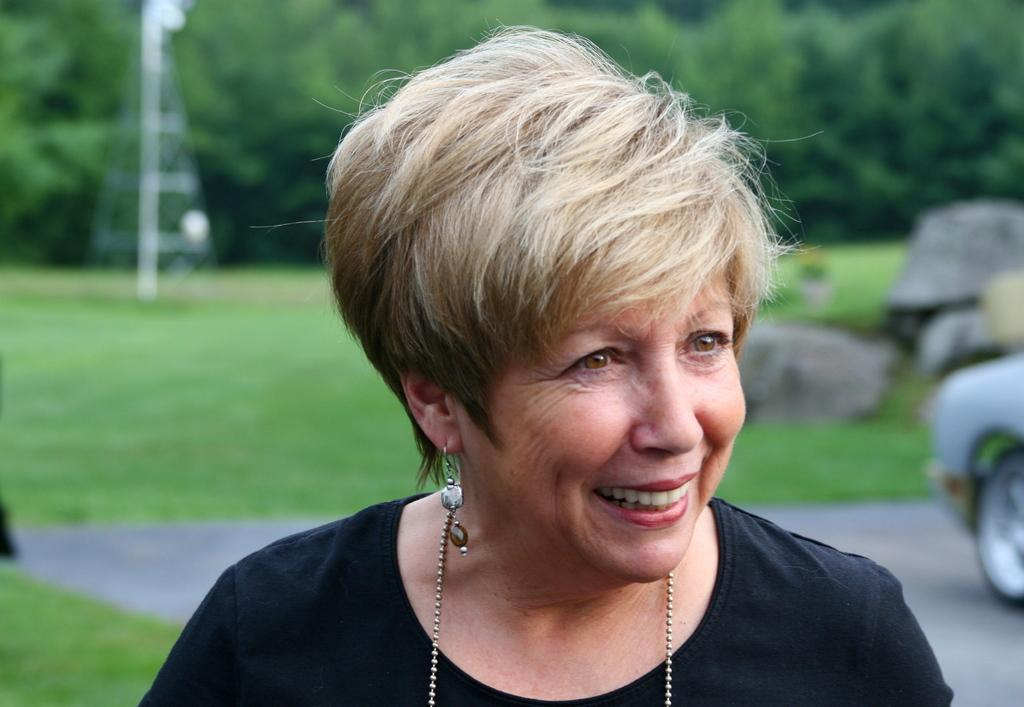Who is present in the image? There is a woman in the image. What is the landscape behind the woman? There is a land covered with grass behind the woman. What can be seen beyond the grassy land? There are many trees behind the grassy land. What type of pen is the woman holding in the image? There is no pen visible in the image; the woman is not holding anything. 